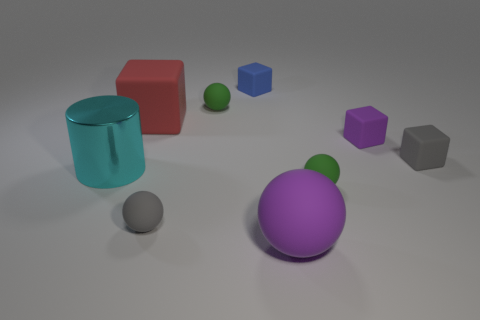Is there any other thing that is made of the same material as the cylinder?
Offer a very short reply. No. There is a big purple rubber thing; are there any tiny green matte balls on the left side of it?
Make the answer very short. Yes. Is the material of the gray cube the same as the large cyan cylinder?
Your answer should be very brief. No. What color is the big rubber object that is the same shape as the tiny blue matte object?
Provide a succinct answer. Red. Do the tiny ball behind the small gray cube and the big shiny thing have the same color?
Provide a succinct answer. No. What number of green objects have the same material as the purple block?
Provide a succinct answer. 2. What number of big purple matte spheres are to the right of the big cylinder?
Provide a short and direct response. 1. How big is the red object?
Give a very brief answer. Large. What color is the rubber ball that is the same size as the cyan metal thing?
Your response must be concise. Purple. Is there a big thing that has the same color as the big block?
Make the answer very short. No. 